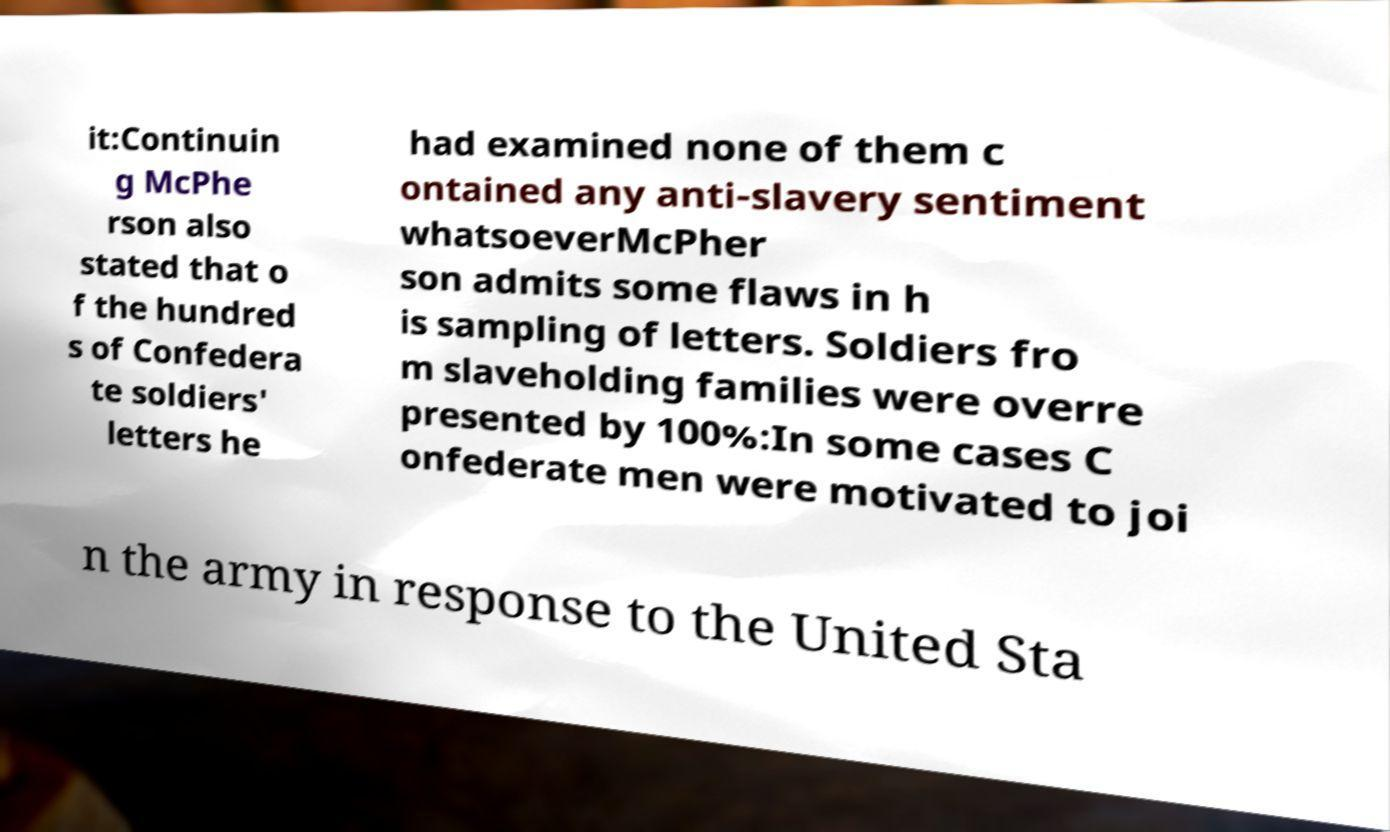For documentation purposes, I need the text within this image transcribed. Could you provide that? it:Continuin g McPhe rson also stated that o f the hundred s of Confedera te soldiers' letters he had examined none of them c ontained any anti-slavery sentiment whatsoeverMcPher son admits some flaws in h is sampling of letters. Soldiers fro m slaveholding families were overre presented by 100%:In some cases C onfederate men were motivated to joi n the army in response to the United Sta 